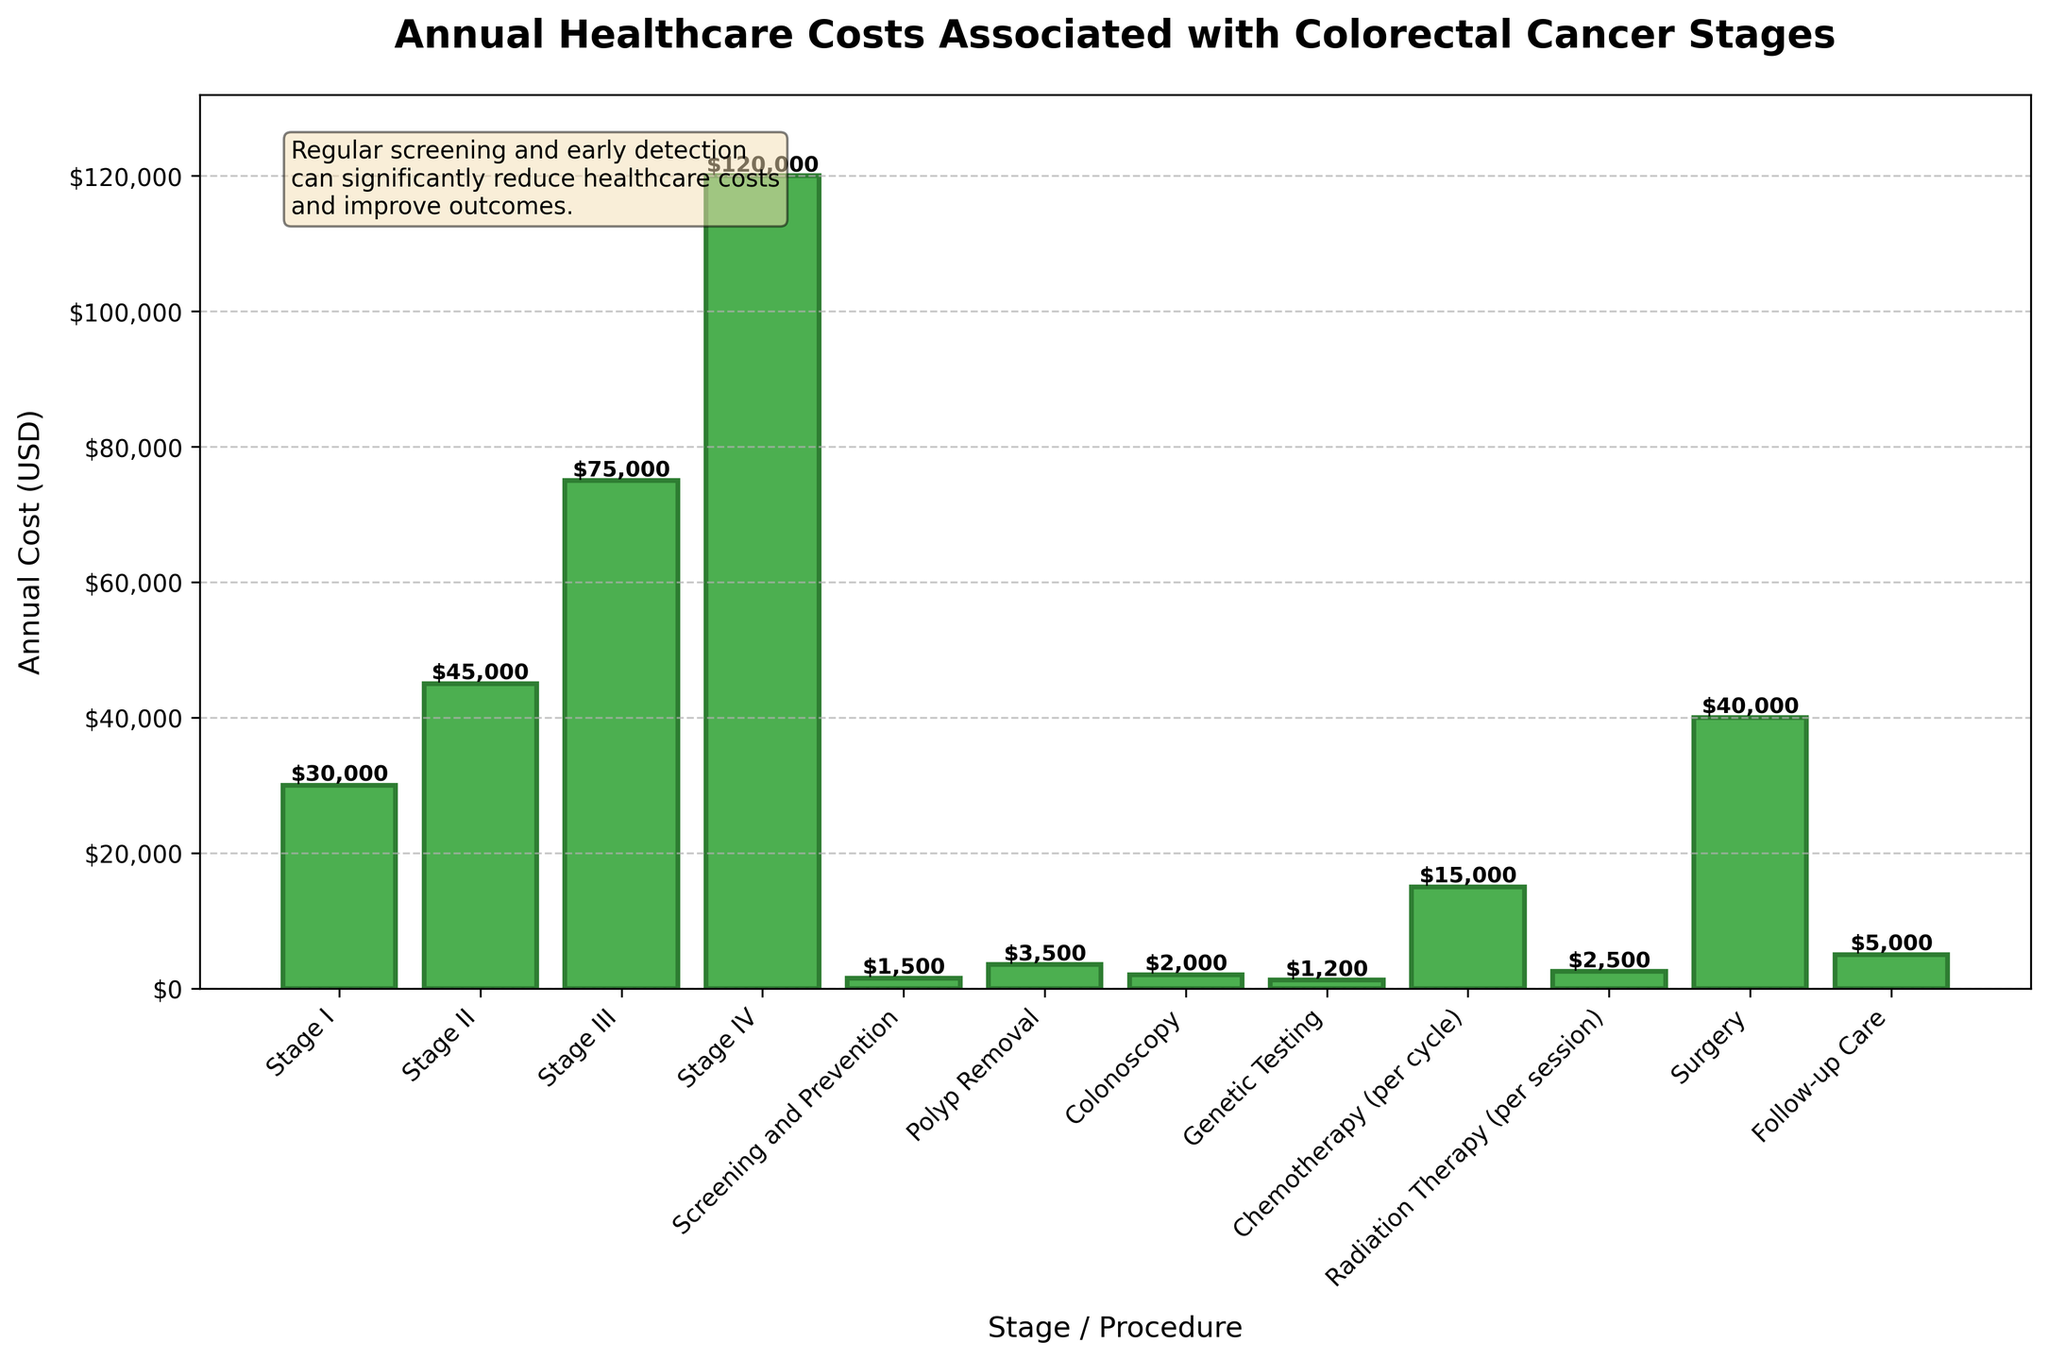What is the annual cost for Stage IV colorectal cancer? The bar for Stage IV shows an annual cost. Directly read the value from above the bar.
Answer: $120,000 Compare the costs of Stage I and Stage II colorectal cancer; which is higher and by how much? The annual cost for Stage I is $30,000 while for Stage II it is $45,000. Subtract the Stage I cost from Stage II cost (45,000 - 30,000).
Answer: Stage II, $15,000 What is the average annual cost for all stages of colorectal cancer (Stage I to Stage IV)? Sum the costs of Stage I to Stage IV and divide by the number of stages. The total is ($30,000 + $45,000 + $75,000 + $120,000) = $270,000. Divide by 4.
Answer: $67,500 What procedure is the costliest per session/cycle and what is its cost? Identify the procedure with the highest cost among Polyp Removal, Colonoscopy, Genetic Testing, Chemotherapy (per cycle), Radiation Therapy (per session), Surgery, and Follow-up Care by comparing their heights. The tallest bar is for Surgery at $40,000.
Answer: Surgery, $40,000 How much more is spent on chemotherapy per cycle compared to genetic testing annually? Chemotherapy cost per cycle is $15,000, and genetic testing cost annually is $1,200. Subtract the genetic testing cost from chemotherapy cost (15,000 - 1,200).
Answer: $13,800 What is the overall cost of screening and prevention, polyp removal, and colonoscopy combined? Sum the costs of Screening and Prevention ($1,500), Polyp Removal ($3,500), and Colonoscopy ($2,000). The total cost is (1,500 + 3,500 + 2,000).
Answer: $7,000 Among all stages of colorectal cancer and related procedures, which has the lowest cost? Identify the shortest bar in the plot, which represents Genetic Testing at $1,200.
Answer: Genetic Testing, $1,200 Estimate the total annual cost if a patient undergoes chemotherapy for 5 cycles and radiation therapy for 3 sessions in a year. Multiply the cost per chemotherapy cycle ($15,000) by 5 and the cost per radiation therapy session ($2,500) by 3, then sum them. The total cost is (15,000 * 5) + (2,500 * 3) = $75,000 + $7,500.
Answer: $82,500 By what factor is the cost of Stage IV colorectal cancer greater than the cost of Stage I? Divide the cost of Stage IV by the cost of Stage I. That is $120,000 / $30,000.
Answer: 4 If the cost of follow-up care is $5,000 annually, how many years would it take for follow-up care to reach the cost of Stage II colorectal cancer? Divide the cost of Stage II colorectal cancer ($45,000) by the annual cost of follow-up care ($5,000) to get the number of years. 45,000 / 5,000.
Answer: 9 years 